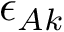Convert formula to latex. <formula><loc_0><loc_0><loc_500><loc_500>\epsilon _ { A k }</formula> 